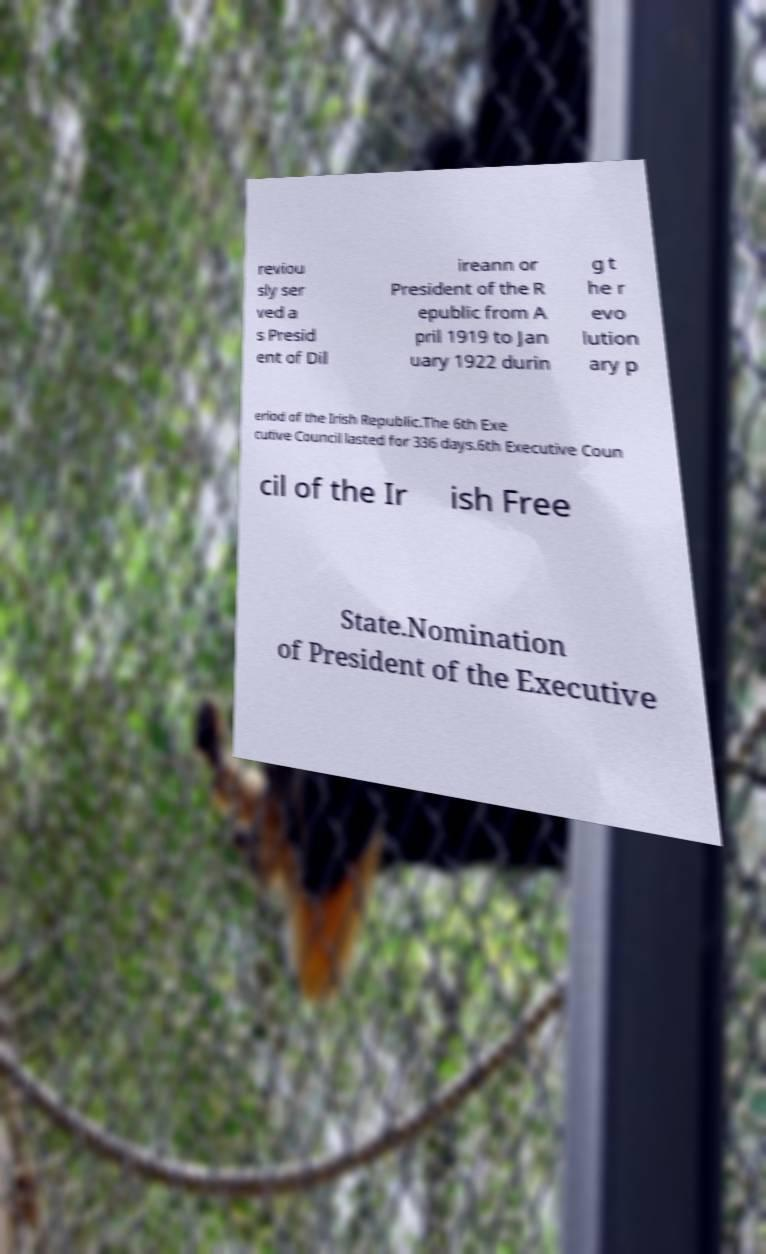What messages or text are displayed in this image? I need them in a readable, typed format. reviou sly ser ved a s Presid ent of Dil ireann or President of the R epublic from A pril 1919 to Jan uary 1922 durin g t he r evo lution ary p eriod of the Irish Republic.The 6th Exe cutive Council lasted for 336 days.6th Executive Coun cil of the Ir ish Free State.Nomination of President of the Executive 